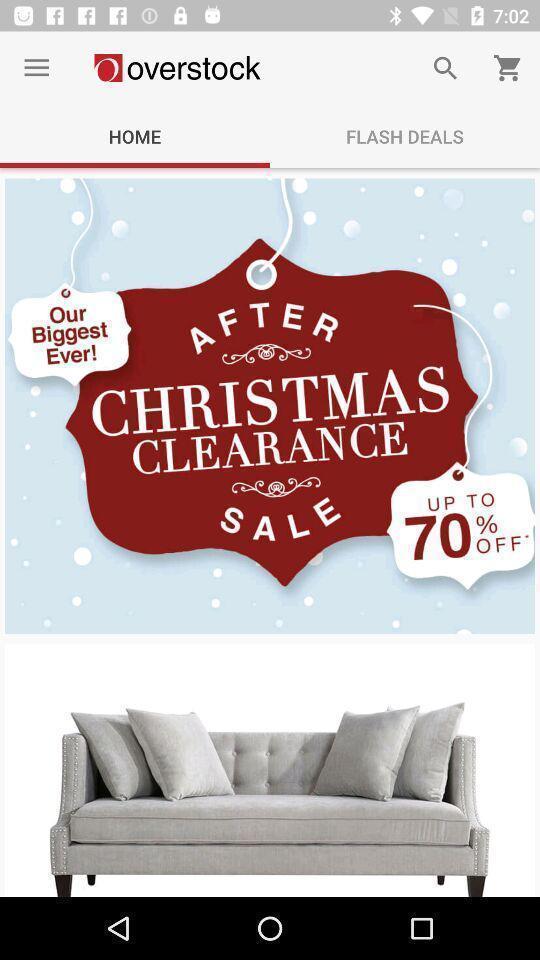Describe the content in this image. Screen page of a shopping application. 